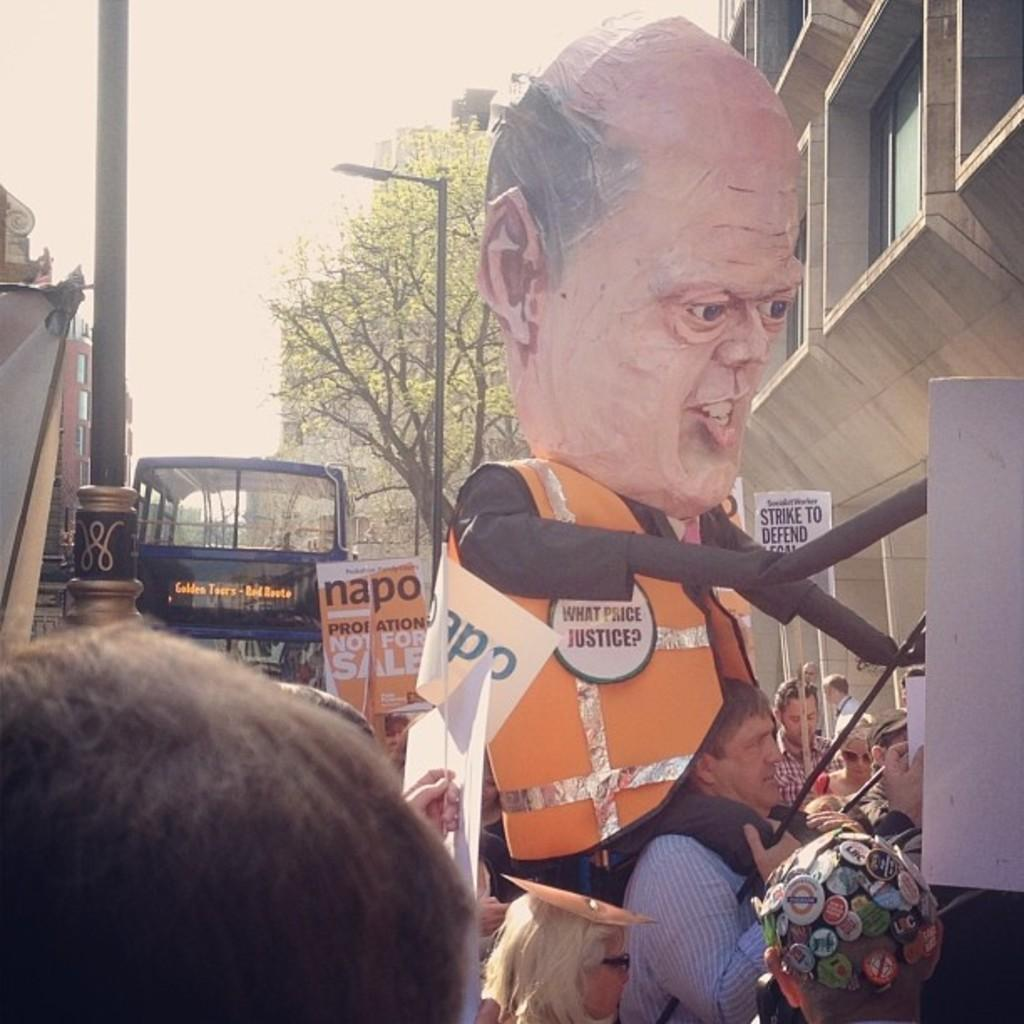What can be seen in the image involving people? There are people standing in the image. What natural element is present in the image? There is a tree in the image. What mode of transportation is visible in the image? There is a bus in the image. What type of structure can be seen in the image? There is a building in the image. What part of the environment is visible in the image? The sky is visible in the image. What color is the gold object being waved by the people in the image? There is no gold object or any object being waved by the people in the image. How do the people in the image say good-bye to each other? The image does not show any interaction between the people, so we cannot determine how they say good-bye to each other. 